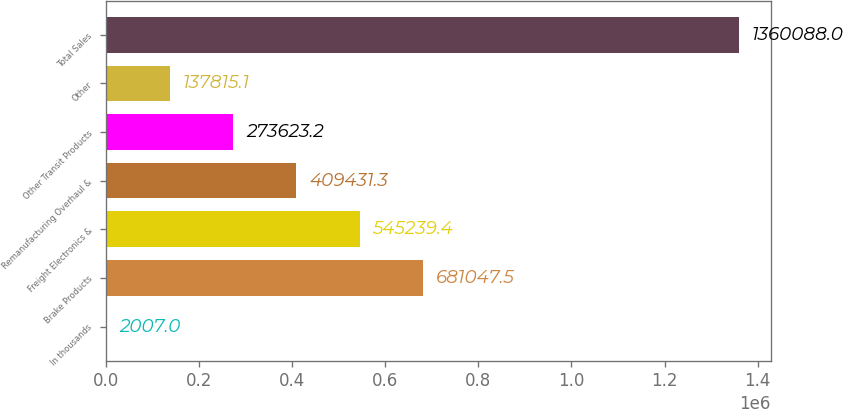Convert chart. <chart><loc_0><loc_0><loc_500><loc_500><bar_chart><fcel>In thousands<fcel>Brake Products<fcel>Freight Electronics &<fcel>Remanufacturing Overhaul &<fcel>Other Transit Products<fcel>Other<fcel>Total Sales<nl><fcel>2007<fcel>681048<fcel>545239<fcel>409431<fcel>273623<fcel>137815<fcel>1.36009e+06<nl></chart> 